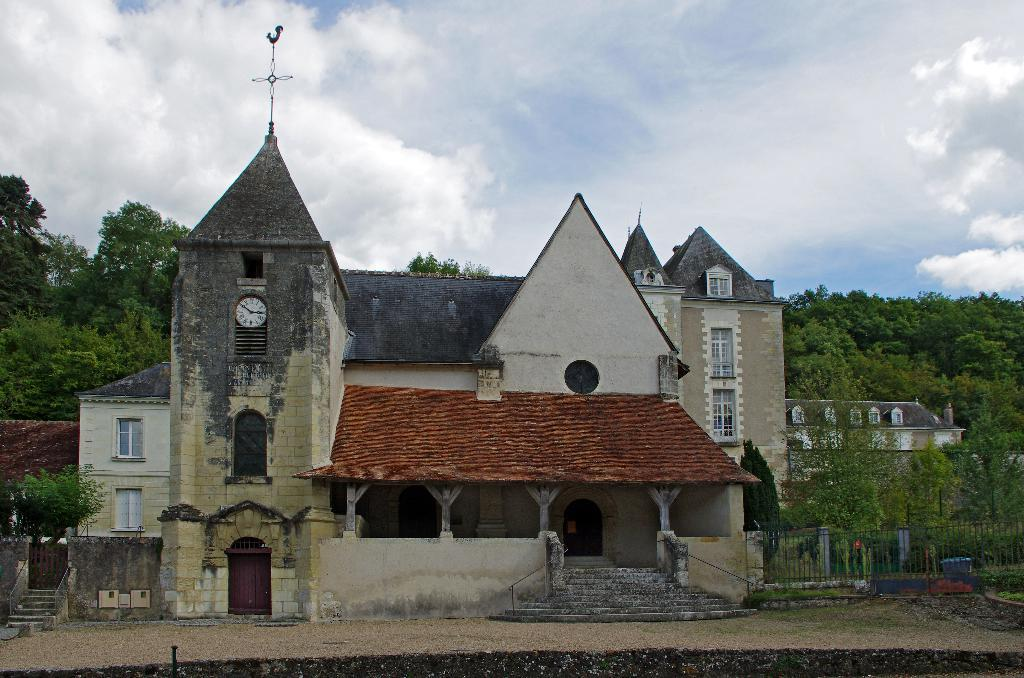What type of structures can be seen in the image? There are buildings in the image. What natural elements are present in the image? There are trees in the image. What type of barrier can be seen in the image? There is a fence in the image. What is visible in the sky in the image? There are clouds visible in the image. What time-related object is present in the image? There is a clock in the image. Can you describe the snake that is slithering through the buildings in the image? There is no snake present in the image; it only features buildings, trees, a fence, clouds, and a clock. 